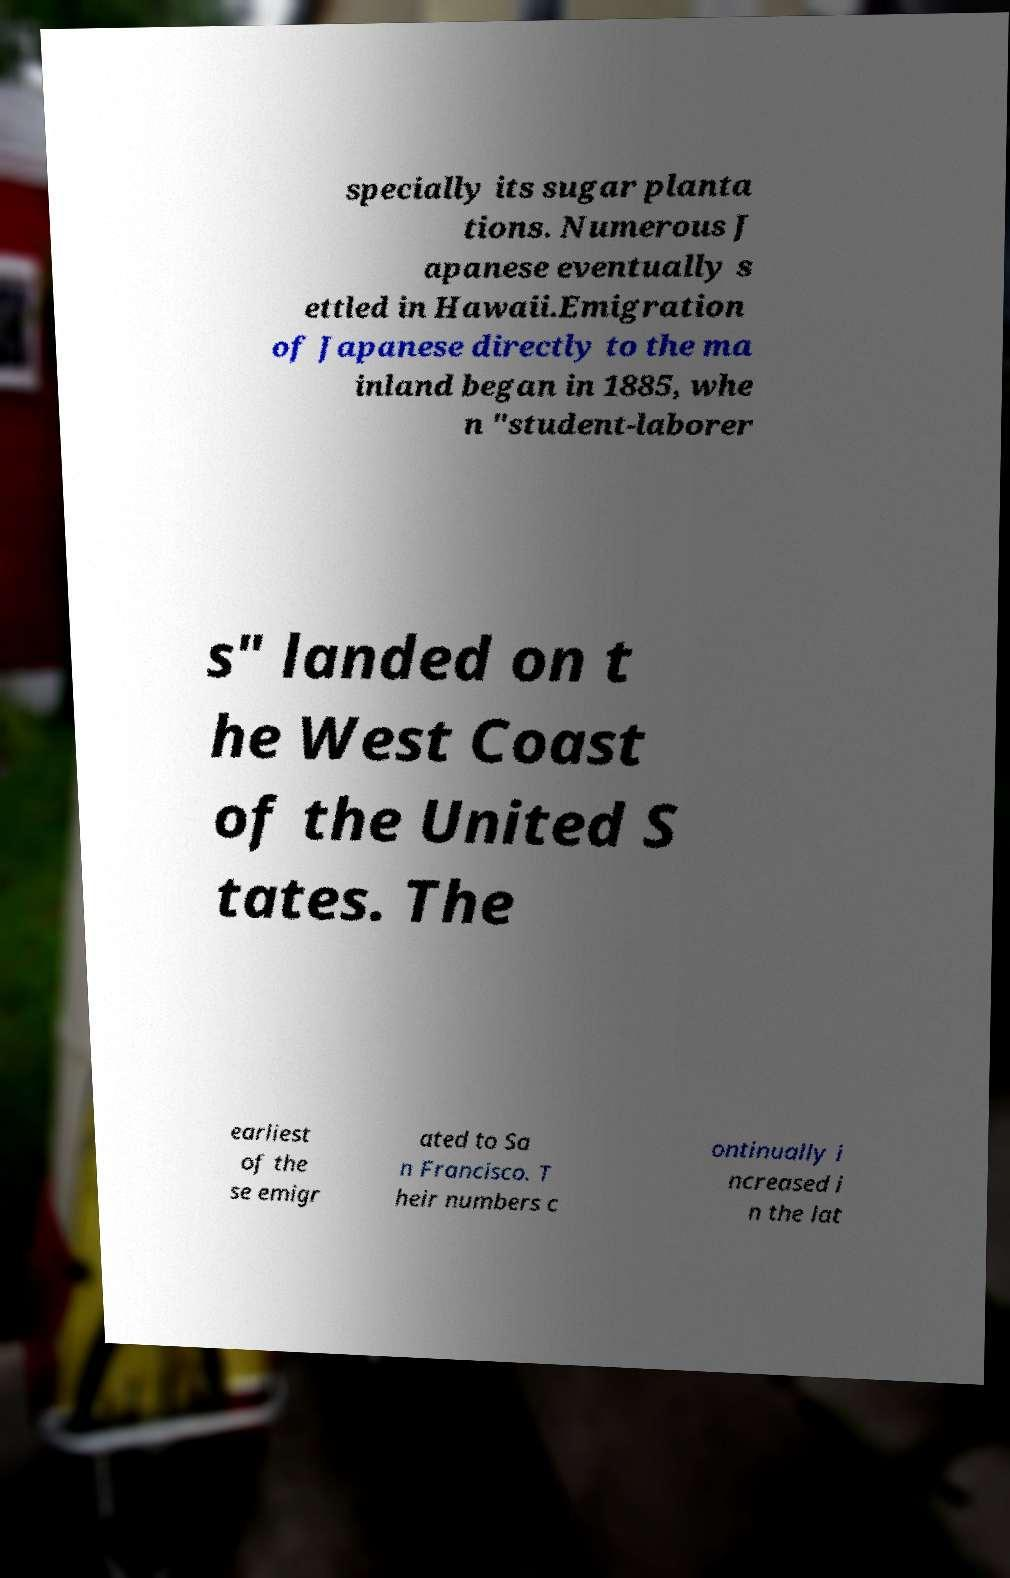Please read and relay the text visible in this image. What does it say? specially its sugar planta tions. Numerous J apanese eventually s ettled in Hawaii.Emigration of Japanese directly to the ma inland began in 1885, whe n "student-laborer s" landed on t he West Coast of the United S tates. The earliest of the se emigr ated to Sa n Francisco. T heir numbers c ontinually i ncreased i n the lat 